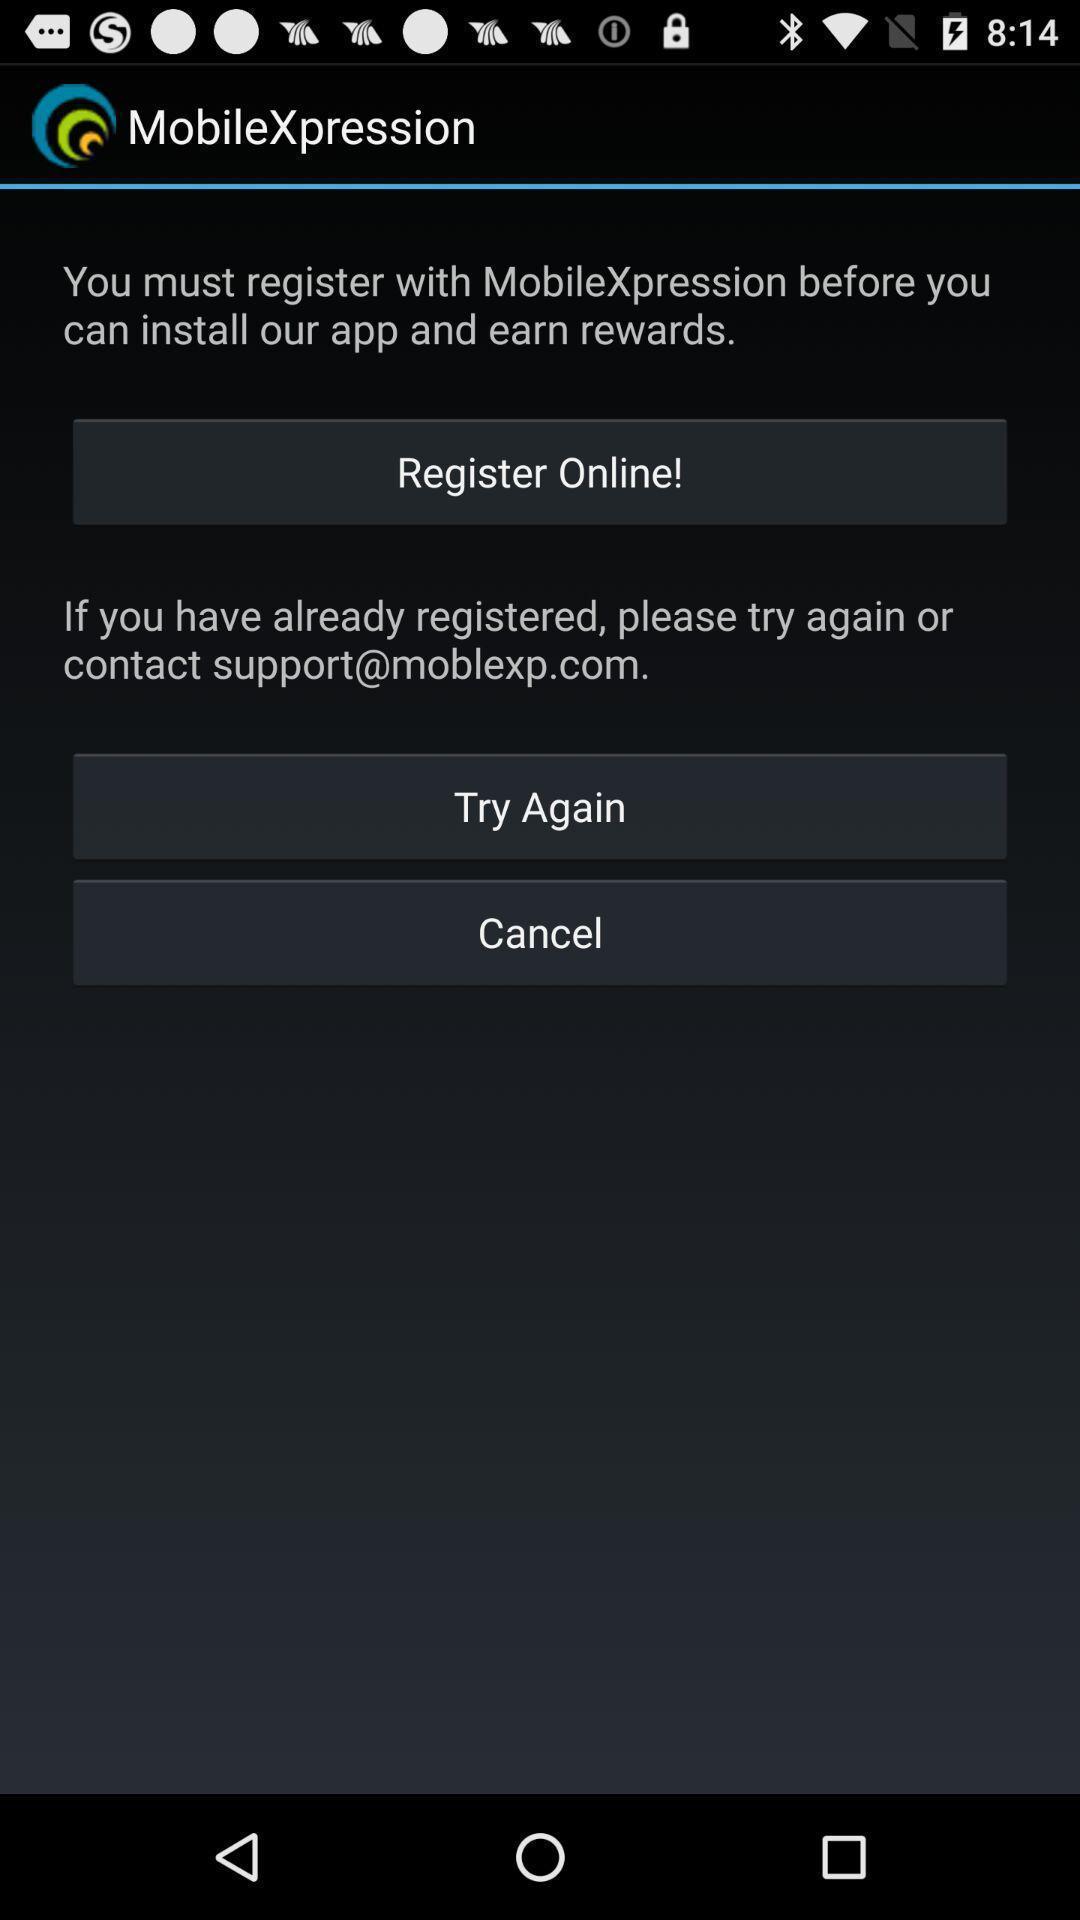Summarize the information in this screenshot. Screen shows to register online for an app. 